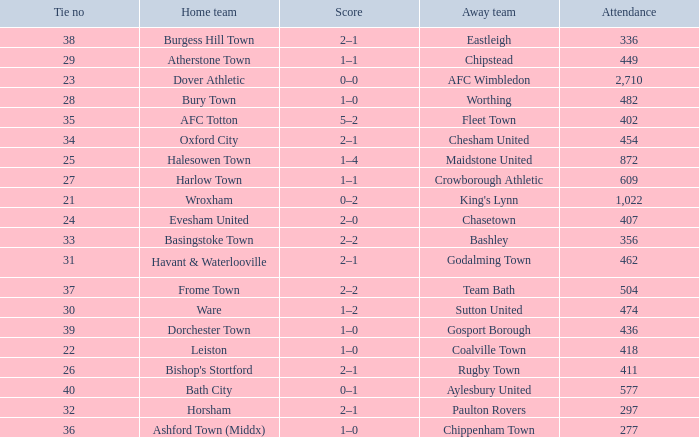What is the away team of the match with a 356 attendance? Bashley. 